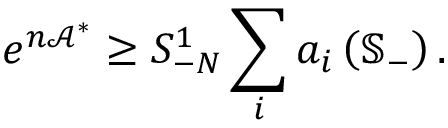Convert formula to latex. <formula><loc_0><loc_0><loc_500><loc_500>e ^ { n \mathcal { A } ^ { \ast } } \geq S _ { - N } ^ { 1 } \sum _ { i } a _ { i } \left ( \mathbb { S } _ { - } \right ) .</formula> 